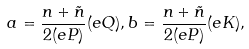<formula> <loc_0><loc_0><loc_500><loc_500>a = \frac { n + \tilde { n } } { 2 ( e P ) } ( e Q ) , b = \frac { n + \tilde { n } } { 2 ( e P ) } ( e K ) ,</formula> 